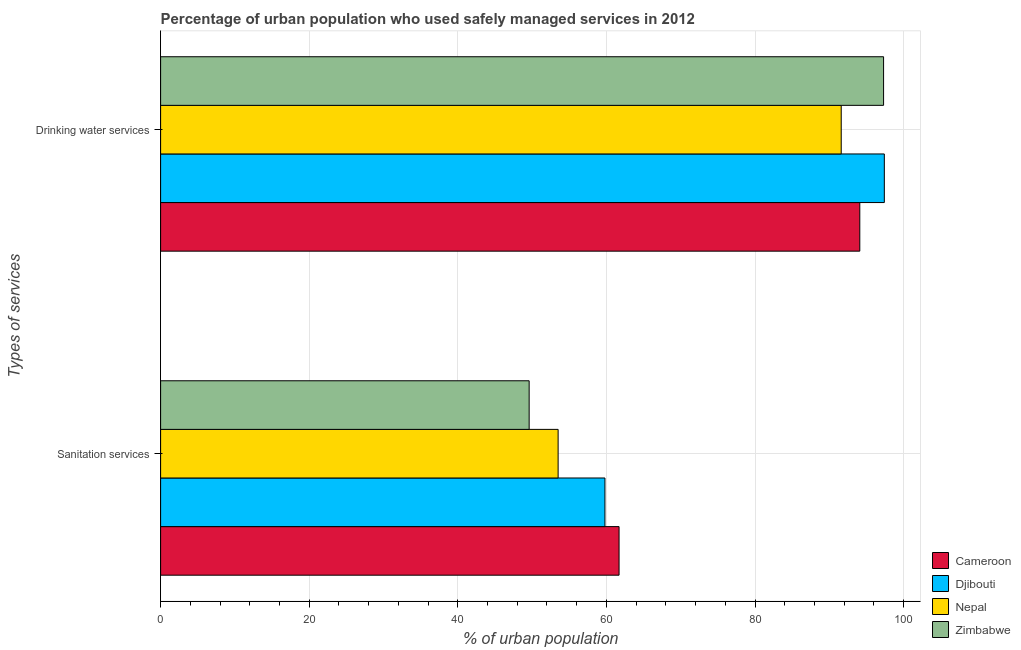How many different coloured bars are there?
Provide a succinct answer. 4. Are the number of bars on each tick of the Y-axis equal?
Give a very brief answer. Yes. How many bars are there on the 1st tick from the bottom?
Keep it short and to the point. 4. What is the label of the 1st group of bars from the top?
Offer a very short reply. Drinking water services. What is the percentage of urban population who used sanitation services in Djibouti?
Your response must be concise. 59.8. Across all countries, what is the maximum percentage of urban population who used drinking water services?
Keep it short and to the point. 97.4. Across all countries, what is the minimum percentage of urban population who used sanitation services?
Your response must be concise. 49.6. In which country was the percentage of urban population who used drinking water services maximum?
Your answer should be very brief. Djibouti. In which country was the percentage of urban population who used drinking water services minimum?
Your answer should be compact. Nepal. What is the total percentage of urban population who used drinking water services in the graph?
Provide a short and direct response. 380.4. What is the difference between the percentage of urban population who used sanitation services in Nepal and that in Zimbabwe?
Provide a short and direct response. 3.9. What is the difference between the percentage of urban population who used sanitation services in Cameroon and the percentage of urban population who used drinking water services in Nepal?
Your answer should be compact. -29.9. What is the average percentage of urban population who used drinking water services per country?
Offer a very short reply. 95.1. What is the difference between the percentage of urban population who used sanitation services and percentage of urban population who used drinking water services in Cameroon?
Your response must be concise. -32.4. What is the ratio of the percentage of urban population who used sanitation services in Nepal to that in Djibouti?
Make the answer very short. 0.89. Is the percentage of urban population who used sanitation services in Djibouti less than that in Nepal?
Give a very brief answer. No. What does the 1st bar from the top in Drinking water services represents?
Give a very brief answer. Zimbabwe. What does the 2nd bar from the bottom in Drinking water services represents?
Your answer should be compact. Djibouti. How many bars are there?
Ensure brevity in your answer.  8. Are all the bars in the graph horizontal?
Your response must be concise. Yes. What is the difference between two consecutive major ticks on the X-axis?
Provide a succinct answer. 20. Are the values on the major ticks of X-axis written in scientific E-notation?
Make the answer very short. No. Does the graph contain grids?
Your answer should be very brief. Yes. How many legend labels are there?
Provide a succinct answer. 4. What is the title of the graph?
Provide a short and direct response. Percentage of urban population who used safely managed services in 2012. What is the label or title of the X-axis?
Give a very brief answer. % of urban population. What is the label or title of the Y-axis?
Provide a succinct answer. Types of services. What is the % of urban population of Cameroon in Sanitation services?
Keep it short and to the point. 61.7. What is the % of urban population of Djibouti in Sanitation services?
Give a very brief answer. 59.8. What is the % of urban population in Nepal in Sanitation services?
Offer a terse response. 53.5. What is the % of urban population of Zimbabwe in Sanitation services?
Your answer should be compact. 49.6. What is the % of urban population of Cameroon in Drinking water services?
Your response must be concise. 94.1. What is the % of urban population of Djibouti in Drinking water services?
Give a very brief answer. 97.4. What is the % of urban population in Nepal in Drinking water services?
Make the answer very short. 91.6. What is the % of urban population in Zimbabwe in Drinking water services?
Offer a very short reply. 97.3. Across all Types of services, what is the maximum % of urban population in Cameroon?
Your answer should be very brief. 94.1. Across all Types of services, what is the maximum % of urban population in Djibouti?
Offer a terse response. 97.4. Across all Types of services, what is the maximum % of urban population of Nepal?
Provide a short and direct response. 91.6. Across all Types of services, what is the maximum % of urban population in Zimbabwe?
Your response must be concise. 97.3. Across all Types of services, what is the minimum % of urban population of Cameroon?
Provide a short and direct response. 61.7. Across all Types of services, what is the minimum % of urban population in Djibouti?
Your answer should be compact. 59.8. Across all Types of services, what is the minimum % of urban population in Nepal?
Provide a succinct answer. 53.5. Across all Types of services, what is the minimum % of urban population in Zimbabwe?
Your response must be concise. 49.6. What is the total % of urban population of Cameroon in the graph?
Your answer should be very brief. 155.8. What is the total % of urban population of Djibouti in the graph?
Provide a succinct answer. 157.2. What is the total % of urban population in Nepal in the graph?
Make the answer very short. 145.1. What is the total % of urban population of Zimbabwe in the graph?
Your response must be concise. 146.9. What is the difference between the % of urban population in Cameroon in Sanitation services and that in Drinking water services?
Provide a short and direct response. -32.4. What is the difference between the % of urban population in Djibouti in Sanitation services and that in Drinking water services?
Ensure brevity in your answer.  -37.6. What is the difference between the % of urban population of Nepal in Sanitation services and that in Drinking water services?
Your answer should be compact. -38.1. What is the difference between the % of urban population in Zimbabwe in Sanitation services and that in Drinking water services?
Give a very brief answer. -47.7. What is the difference between the % of urban population of Cameroon in Sanitation services and the % of urban population of Djibouti in Drinking water services?
Offer a very short reply. -35.7. What is the difference between the % of urban population of Cameroon in Sanitation services and the % of urban population of Nepal in Drinking water services?
Provide a succinct answer. -29.9. What is the difference between the % of urban population of Cameroon in Sanitation services and the % of urban population of Zimbabwe in Drinking water services?
Offer a terse response. -35.6. What is the difference between the % of urban population of Djibouti in Sanitation services and the % of urban population of Nepal in Drinking water services?
Your response must be concise. -31.8. What is the difference between the % of urban population of Djibouti in Sanitation services and the % of urban population of Zimbabwe in Drinking water services?
Your response must be concise. -37.5. What is the difference between the % of urban population of Nepal in Sanitation services and the % of urban population of Zimbabwe in Drinking water services?
Your response must be concise. -43.8. What is the average % of urban population in Cameroon per Types of services?
Offer a very short reply. 77.9. What is the average % of urban population of Djibouti per Types of services?
Your answer should be very brief. 78.6. What is the average % of urban population of Nepal per Types of services?
Keep it short and to the point. 72.55. What is the average % of urban population in Zimbabwe per Types of services?
Keep it short and to the point. 73.45. What is the difference between the % of urban population of Cameroon and % of urban population of Zimbabwe in Sanitation services?
Offer a very short reply. 12.1. What is the difference between the % of urban population in Cameroon and % of urban population in Nepal in Drinking water services?
Your response must be concise. 2.5. What is the difference between the % of urban population in Djibouti and % of urban population in Zimbabwe in Drinking water services?
Ensure brevity in your answer.  0.1. What is the ratio of the % of urban population in Cameroon in Sanitation services to that in Drinking water services?
Make the answer very short. 0.66. What is the ratio of the % of urban population of Djibouti in Sanitation services to that in Drinking water services?
Give a very brief answer. 0.61. What is the ratio of the % of urban population in Nepal in Sanitation services to that in Drinking water services?
Offer a very short reply. 0.58. What is the ratio of the % of urban population of Zimbabwe in Sanitation services to that in Drinking water services?
Give a very brief answer. 0.51. What is the difference between the highest and the second highest % of urban population of Cameroon?
Your response must be concise. 32.4. What is the difference between the highest and the second highest % of urban population in Djibouti?
Make the answer very short. 37.6. What is the difference between the highest and the second highest % of urban population in Nepal?
Keep it short and to the point. 38.1. What is the difference between the highest and the second highest % of urban population in Zimbabwe?
Give a very brief answer. 47.7. What is the difference between the highest and the lowest % of urban population in Cameroon?
Provide a short and direct response. 32.4. What is the difference between the highest and the lowest % of urban population of Djibouti?
Offer a very short reply. 37.6. What is the difference between the highest and the lowest % of urban population in Nepal?
Offer a very short reply. 38.1. What is the difference between the highest and the lowest % of urban population of Zimbabwe?
Provide a succinct answer. 47.7. 